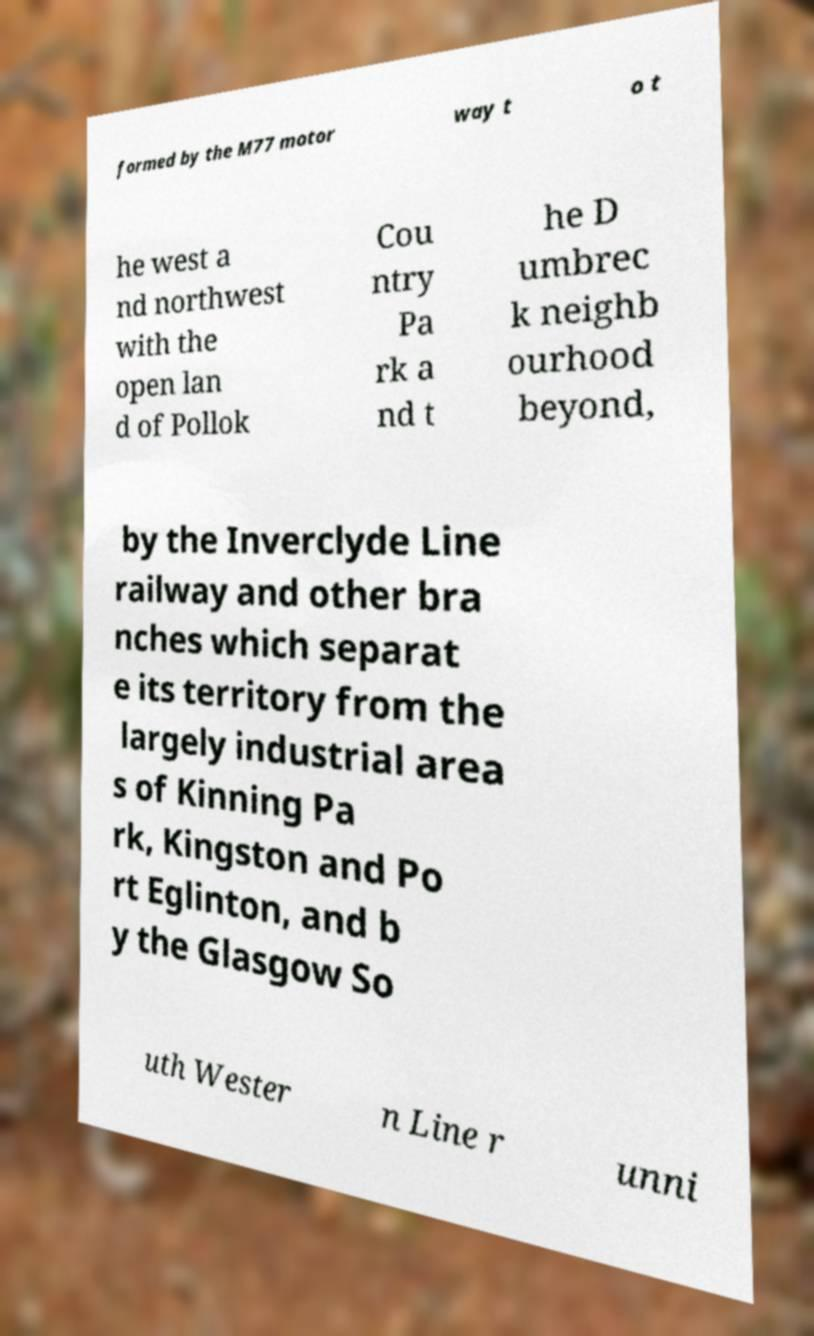Can you read and provide the text displayed in the image?This photo seems to have some interesting text. Can you extract and type it out for me? formed by the M77 motor way t o t he west a nd northwest with the open lan d of Pollok Cou ntry Pa rk a nd t he D umbrec k neighb ourhood beyond, by the Inverclyde Line railway and other bra nches which separat e its territory from the largely industrial area s of Kinning Pa rk, Kingston and Po rt Eglinton, and b y the Glasgow So uth Wester n Line r unni 